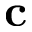<formula> <loc_0><loc_0><loc_500><loc_500>c</formula> 